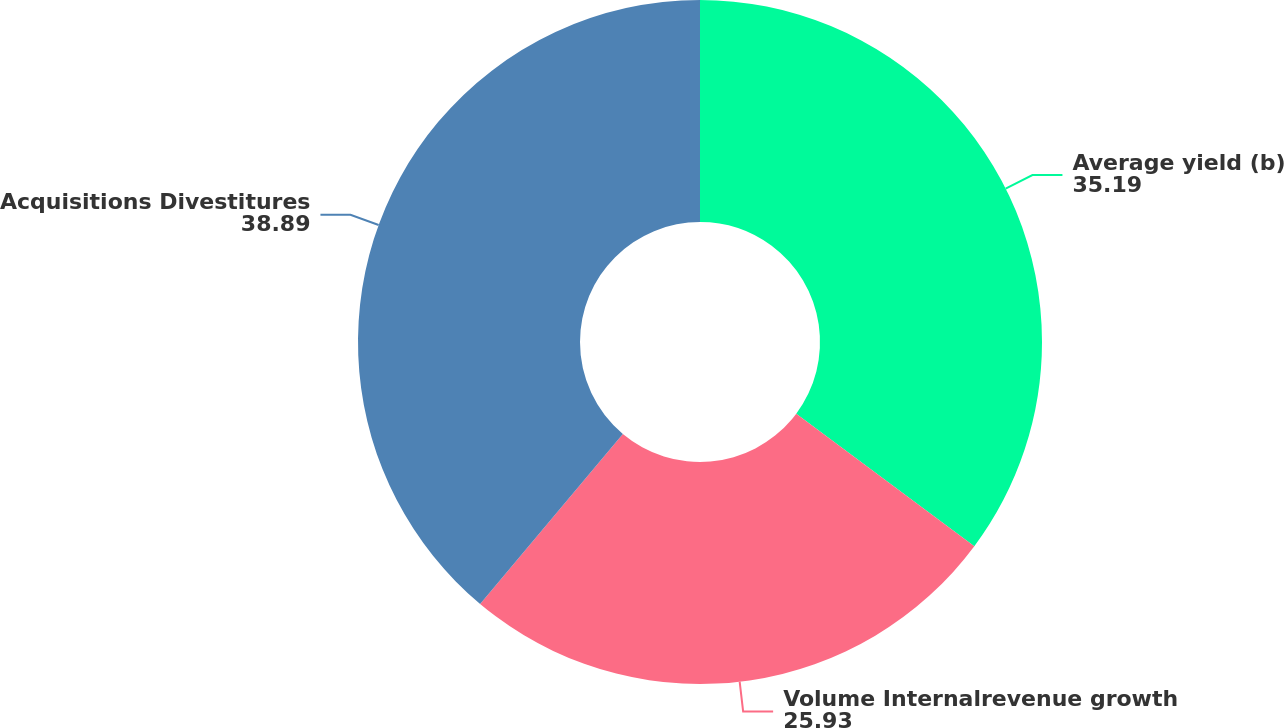Convert chart to OTSL. <chart><loc_0><loc_0><loc_500><loc_500><pie_chart><fcel>Average yield (b)<fcel>Volume Internalrevenue growth<fcel>Acquisitions Divestitures<nl><fcel>35.19%<fcel>25.93%<fcel>38.89%<nl></chart> 